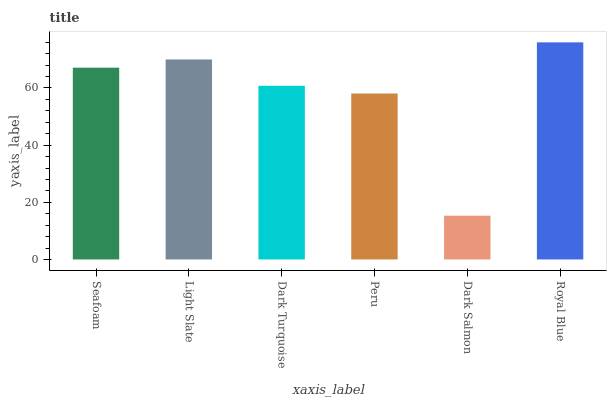Is Dark Salmon the minimum?
Answer yes or no. Yes. Is Royal Blue the maximum?
Answer yes or no. Yes. Is Light Slate the minimum?
Answer yes or no. No. Is Light Slate the maximum?
Answer yes or no. No. Is Light Slate greater than Seafoam?
Answer yes or no. Yes. Is Seafoam less than Light Slate?
Answer yes or no. Yes. Is Seafoam greater than Light Slate?
Answer yes or no. No. Is Light Slate less than Seafoam?
Answer yes or no. No. Is Seafoam the high median?
Answer yes or no. Yes. Is Dark Turquoise the low median?
Answer yes or no. Yes. Is Dark Turquoise the high median?
Answer yes or no. No. Is Royal Blue the low median?
Answer yes or no. No. 